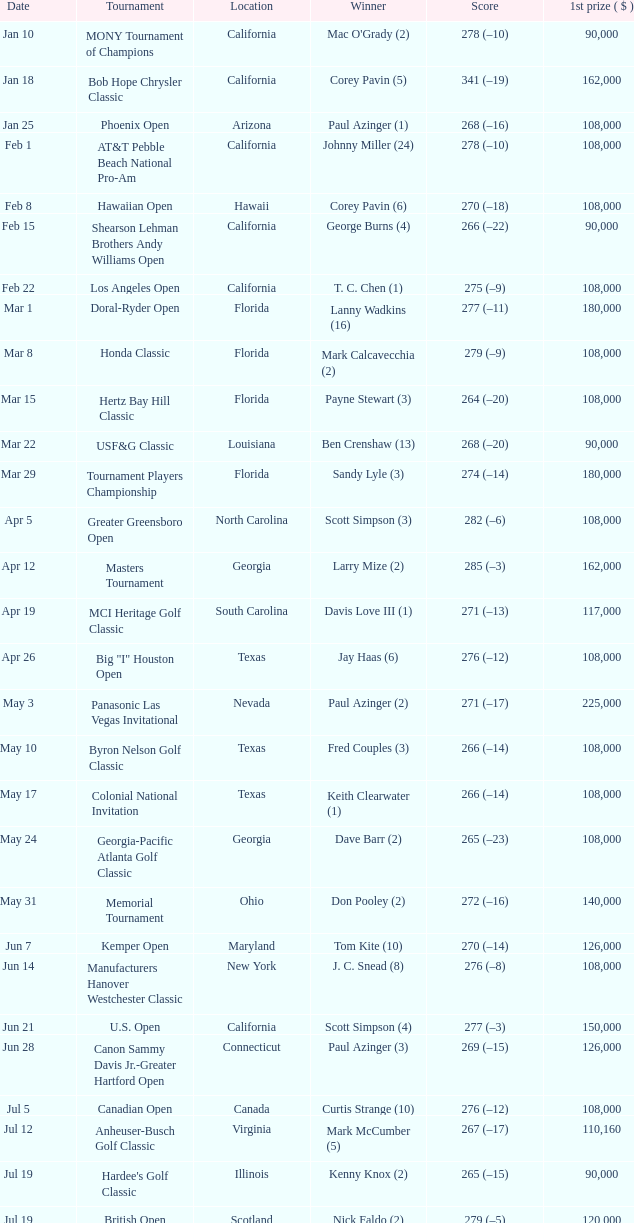What is the date where the winner was Tom Kite (10)? Jun 7. 